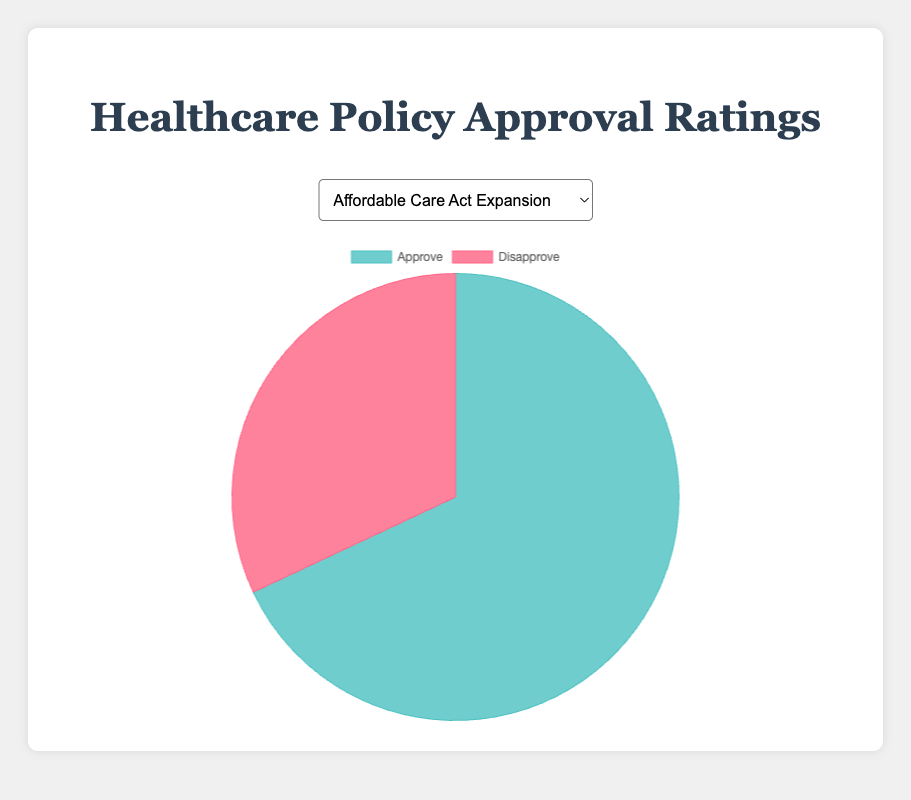What percentage of respondents approve of the Affordable Care Act Expansion policy? By looking at the pie chart, we can see the approval section and read the label that shows the percentage value.
Answer: 68% Which policy has the highest public approval rating? By comparing all the pie charts, we see that the "Pharmaceutical Price Regulation" policy shows the highest percentage for approval, indicated by the aproval section's label.
Answer: Pharmaceutical Price Regulation How much higher is the approval rating for "Expansion of Medicaid" compared to "Short-Term Health Plans Ban"? The approval rating for "Expansion of Medicaid" is 64%, and for "Short-Term Health Plans Ban" it is 49%. Subtracting 49% from 64% gives us 15%.
Answer: 15% Which policy has the greatest difference between approval and disapproval ratings? A visual inspection shows that the "Pharmaceutical Price Regulation" policy has 72% approval and 28% disapproval, a gap of 44%. No other policy has a greater difference.
Answer: Pharmaceutical Price Regulation Out of all policies, what is the average approval rating? Summing all the approval ratings (68 + 55 + 60 + 72 + 64 + 49) and dividing by the number of policies (6) results in (368 / 6) = 61.33%.
Answer: 61.33% What color represents disapproval in the pie chart? The pie charts consistently use color to indicate approval and disapproval. By referring to any of the charts, we see that the disapproval section is in red.
Answer: Red 